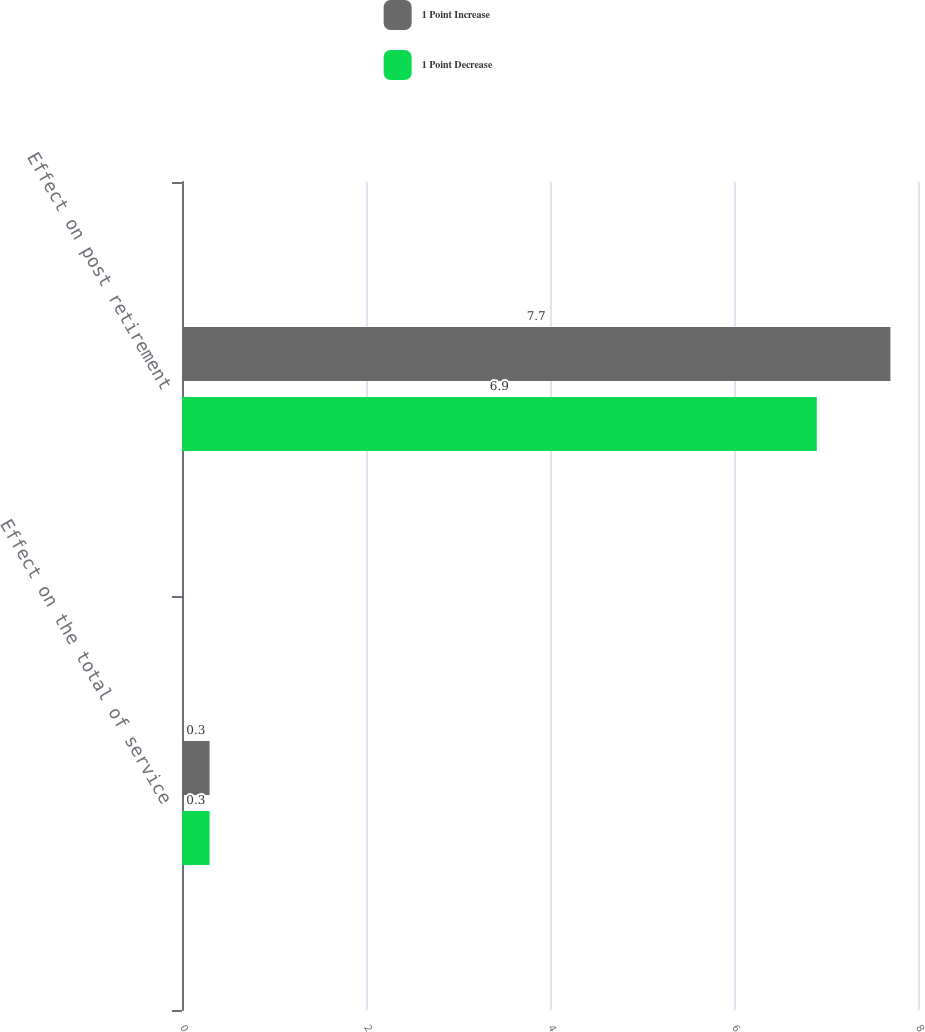<chart> <loc_0><loc_0><loc_500><loc_500><stacked_bar_chart><ecel><fcel>Effect on the total of service<fcel>Effect on post retirement<nl><fcel>1 Point Increase<fcel>0.3<fcel>7.7<nl><fcel>1 Point Decrease<fcel>0.3<fcel>6.9<nl></chart> 